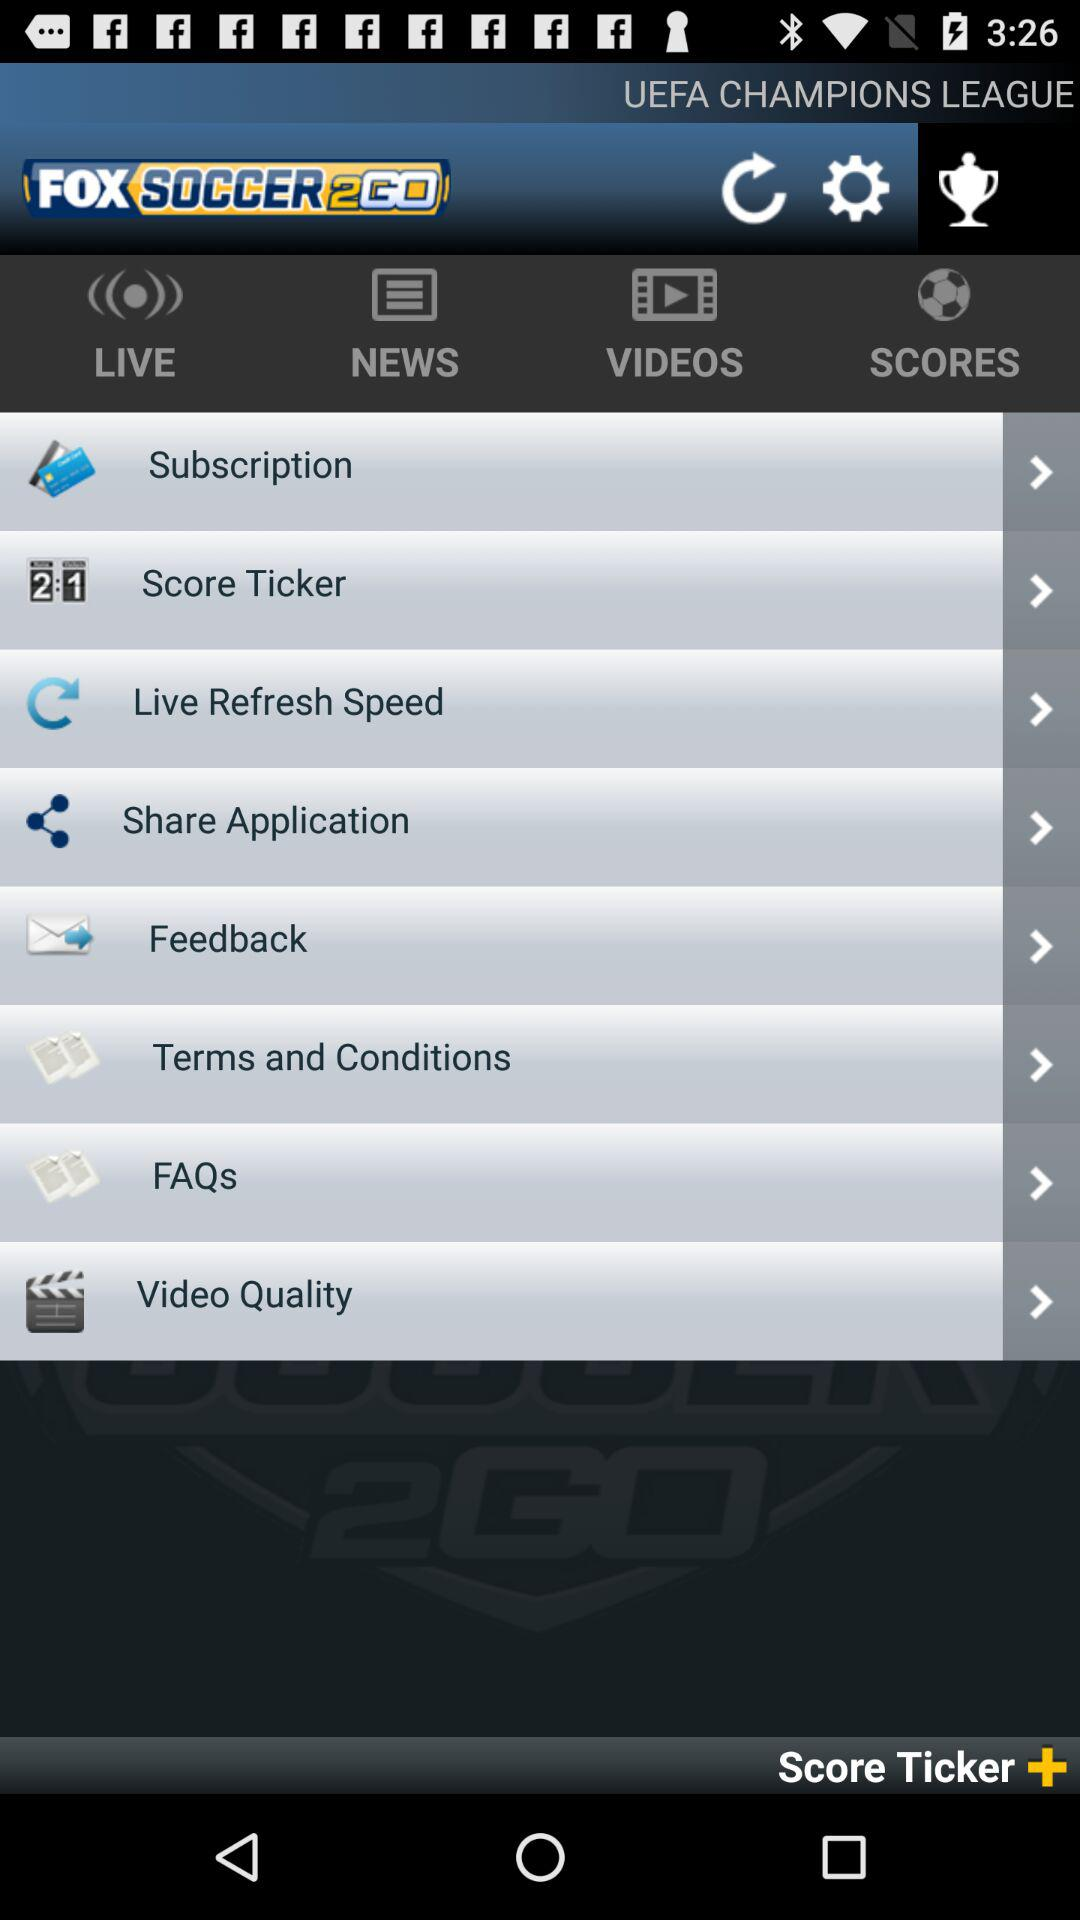What is the name of the application? The name of the application is "FOX SOCCER2GO". 